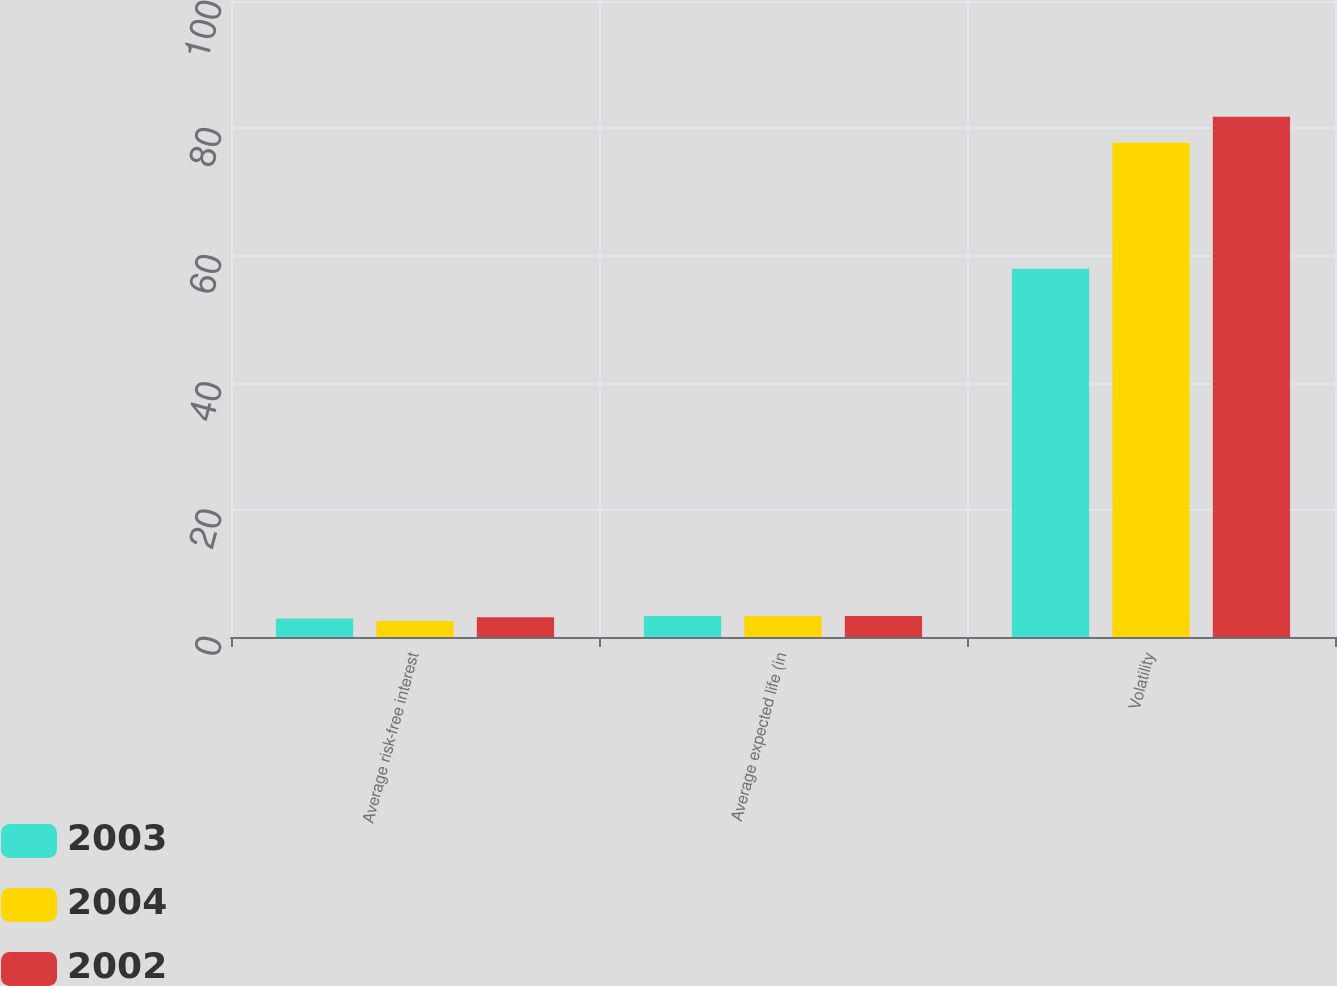Convert chart to OTSL. <chart><loc_0><loc_0><loc_500><loc_500><stacked_bar_chart><ecel><fcel>Average risk-free interest<fcel>Average expected life (in<fcel>Volatility<nl><fcel>2003<fcel>2.9<fcel>3.3<fcel>57.9<nl><fcel>2004<fcel>2.5<fcel>3.3<fcel>77.7<nl><fcel>2002<fcel>3.1<fcel>3.3<fcel>81.8<nl></chart> 